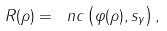<formula> <loc_0><loc_0><loc_500><loc_500>R ( \rho ) = \ n c \left ( \varphi ( \rho ) , s _ { \gamma } \right ) ,</formula> 